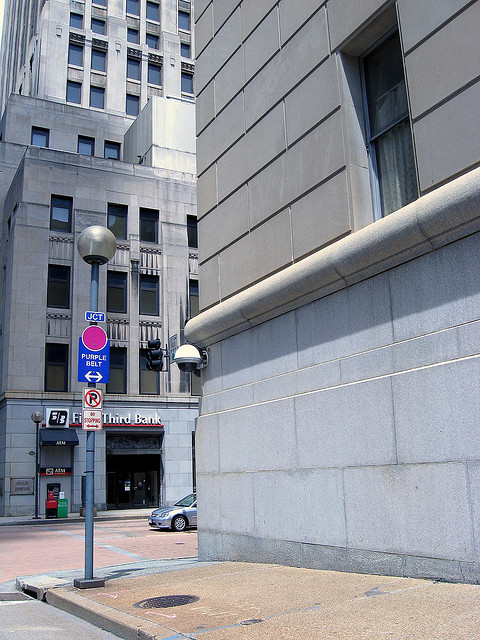Please identify all text content in this image. JCT PURPLA Bank Fi Thind 